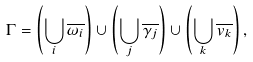Convert formula to latex. <formula><loc_0><loc_0><loc_500><loc_500>\Gamma = \left ( \bigcup _ { i } \overline { \omega _ { i } } \right ) \cup \left ( \bigcup _ { j } \overline { \gamma _ { j } } \right ) \cup \left ( \bigcup _ { k } \overline { v _ { k } } \right ) ,</formula> 